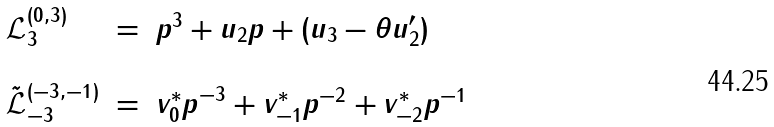Convert formula to latex. <formula><loc_0><loc_0><loc_500><loc_500>\begin{array} { l c l } { \mathcal { L } } _ { 3 } ^ { ( 0 , 3 ) } & = & p ^ { 3 } + u _ { 2 } p + ( u _ { 3 } - \theta u ^ { \prime } _ { 2 } ) \\ \\ { \tilde { \mathcal { L } } } _ { - 3 } ^ { ( - 3 , - 1 ) } & = & { v _ { 0 } ^ { * } p } ^ { - 3 } + v _ { - 1 } ^ { * } p ^ { - 2 } + v _ { - 2 } ^ { * } p ^ { - 1 } \\ \\ \end{array}</formula> 